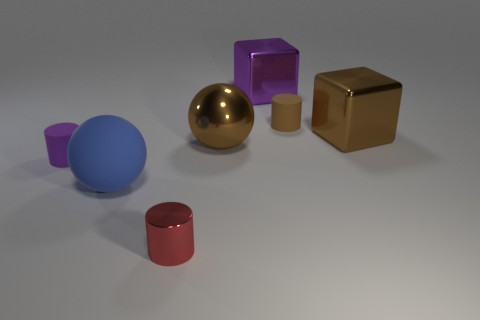Subtract all cylinders. How many objects are left? 4 Subtract all small matte cylinders. How many cylinders are left? 1 Subtract all small purple blocks. Subtract all large brown things. How many objects are left? 5 Add 3 tiny cylinders. How many tiny cylinders are left? 6 Add 3 big brown cubes. How many big brown cubes exist? 4 Add 3 big gray rubber cubes. How many objects exist? 10 Subtract all purple blocks. How many blocks are left? 1 Subtract 1 purple cylinders. How many objects are left? 6 Subtract 1 spheres. How many spheres are left? 1 Subtract all purple blocks. Subtract all purple balls. How many blocks are left? 1 